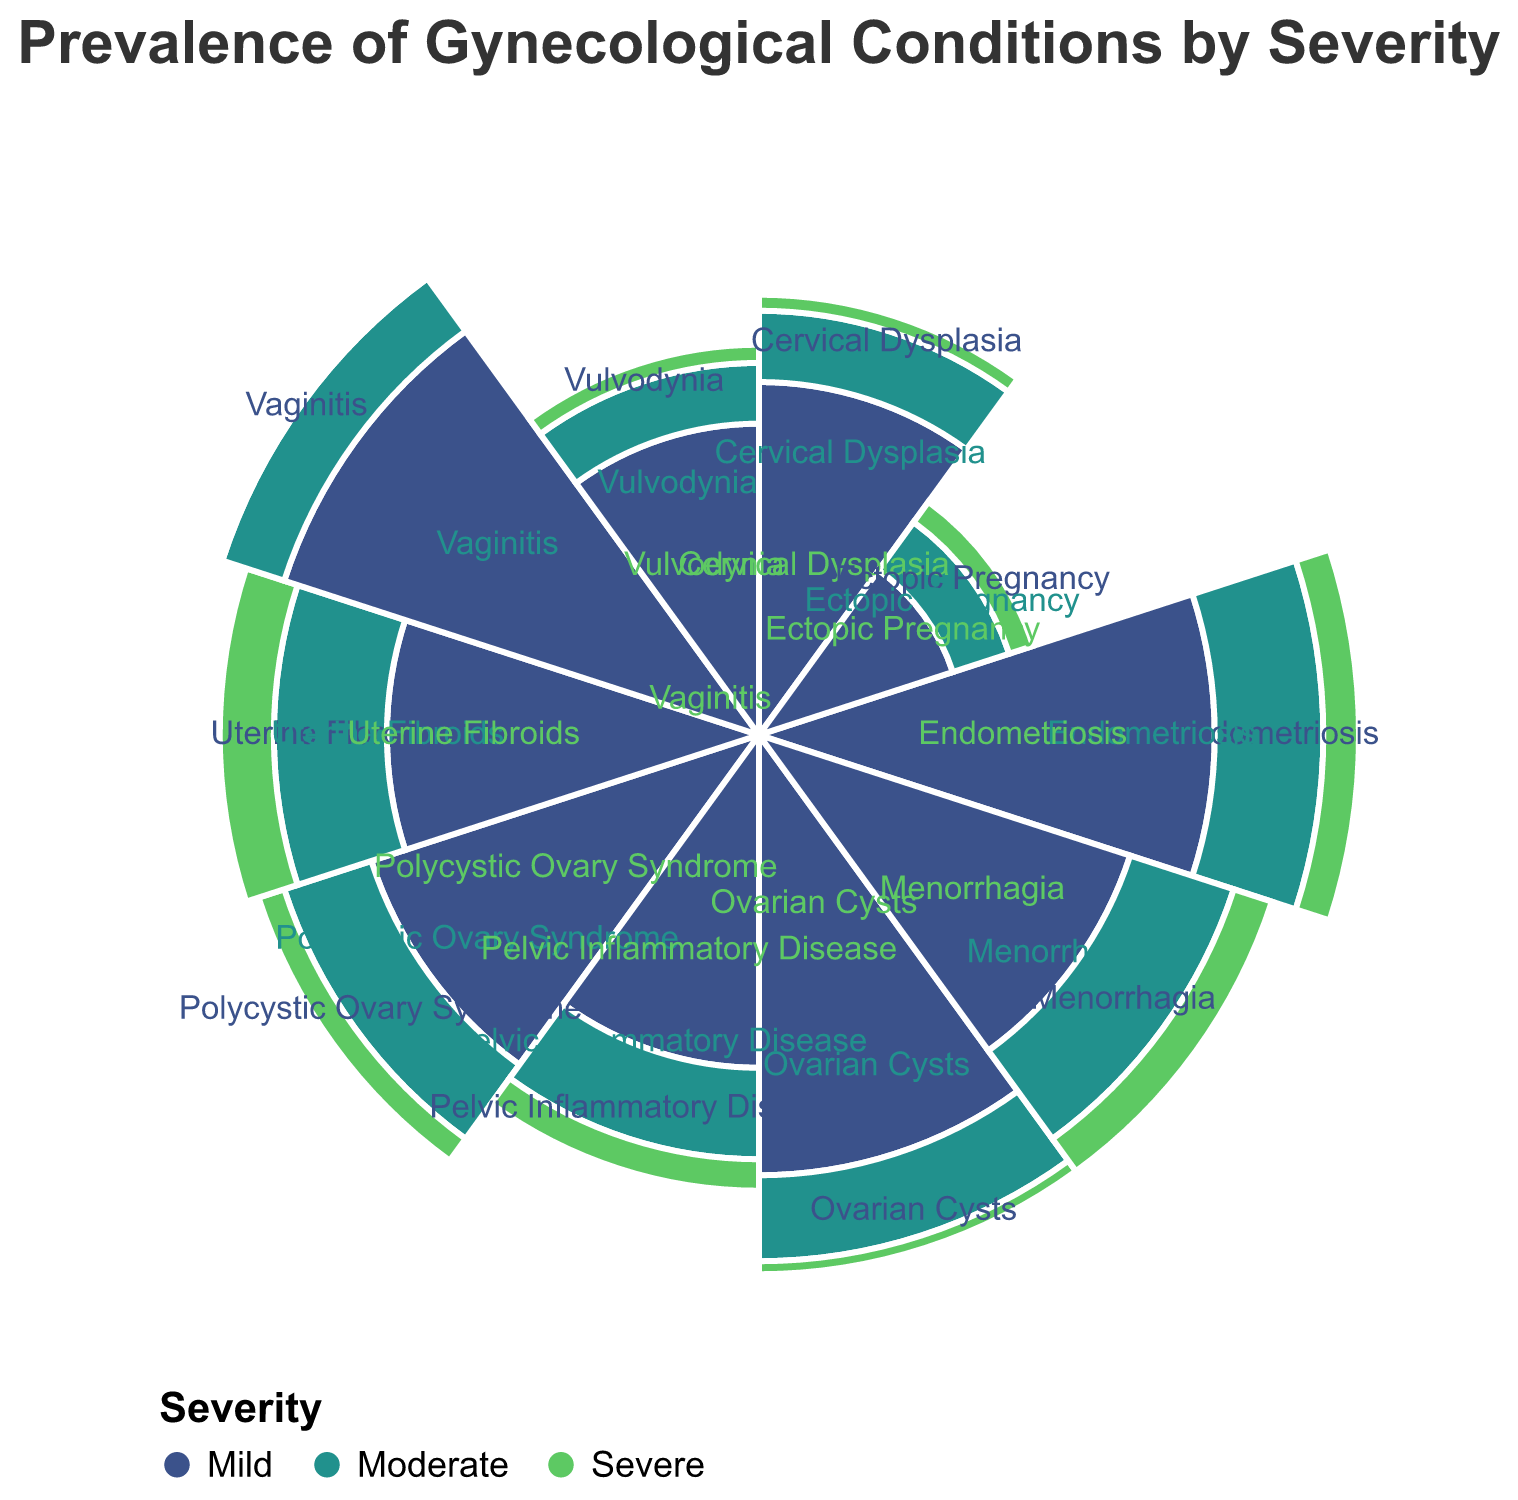What is the severity with the highest prevalence for Endometriosis? To find this, look at the frequencies of Mild, Moderate, and Severe for Endometriosis. The highest value is 15 for Mild.
Answer: Mild Which condition has the lowest prevalence for Severe cases? Examine the values for the Severe category across all conditions. Vaginitis and Cervical Dysplasia have the lowest value of 0.
Answer: Vaginitis and Cervical Dysplasia What is the total number of cases for Polycystic Ovary Syndrome? Sum the values for Mild, Moderate, and Severe for Polycystic Ovary Syndrome. This gives 12 (Mild) + 6 (Moderate) + 2 (Severe) = 20.
Answer: 20 Which condition has the highest number of Mild cases? Look for the highest value in the Mild category across all conditions. Vaginitis has the highest value with 18.
Answer: Vaginitis How does the number of Severe cases for Uterine Fibroids compare to that of Menorrhagia? Compare the Severe cases for Uterine Fibroids and Menorrhagia. Uterine Fibroids has 4 while Menorrhagia has 3, so Uterine Fibroids is higher.
Answer: Uterine Fibroids is higher What is the condition with the highest combined prevalence for Moderate and Severe cases? Combine the values for Moderate and Severe for each condition and find the highest sum. Endometriosis has 8 (Moderate) + 3 (Severe) = 11.
Answer: Endometriosis What is the average number of Moderate cases across all conditions? Add up the Moderate values for all conditions and divide by the number of conditions. The sum is 53, and there are 10 conditions, so the average is 53/10 = 5.3.
Answer: 5.3 